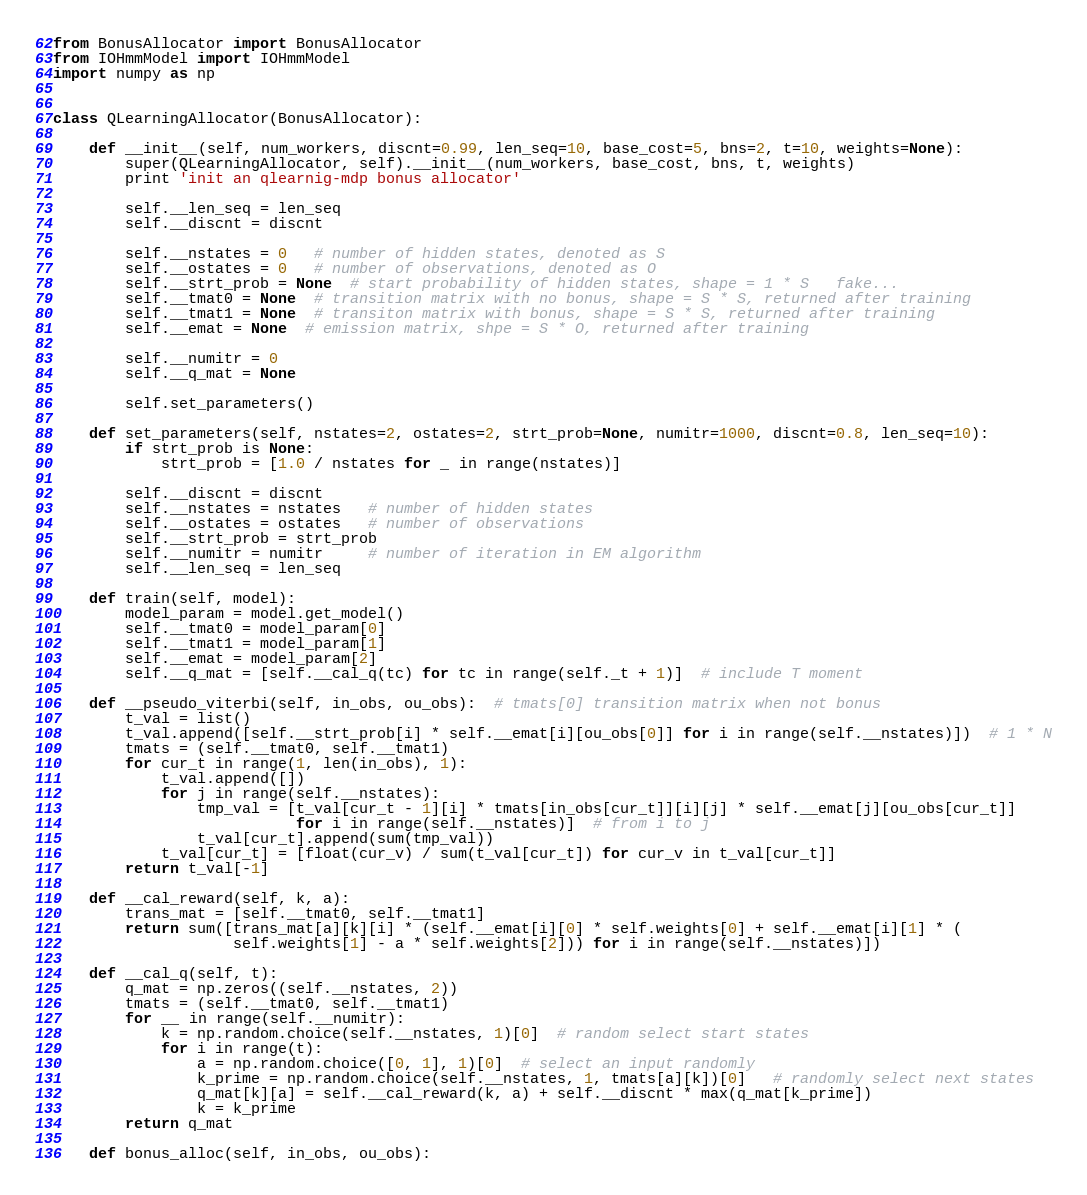Convert code to text. <code><loc_0><loc_0><loc_500><loc_500><_Python_>from BonusAllocator import BonusAllocator
from IOHmmModel import IOHmmModel
import numpy as np


class QLearningAllocator(BonusAllocator):

    def __init__(self, num_workers, discnt=0.99, len_seq=10, base_cost=5, bns=2, t=10, weights=None):
        super(QLearningAllocator, self).__init__(num_workers, base_cost, bns, t, weights)
        print 'init an qlearnig-mdp bonus allocator'

        self.__len_seq = len_seq
        self.__discnt = discnt

        self.__nstates = 0   # number of hidden states, denoted as S
        self.__ostates = 0   # number of observations, denoted as O
        self.__strt_prob = None  # start probability of hidden states, shape = 1 * S   fake...
        self.__tmat0 = None  # transition matrix with no bonus, shape = S * S, returned after training
        self.__tmat1 = None  # transiton matrix with bonus, shape = S * S, returned after training
        self.__emat = None  # emission matrix, shpe = S * O, returned after training

        self.__numitr = 0
        self.__q_mat = None

        self.set_parameters()

    def set_parameters(self, nstates=2, ostates=2, strt_prob=None, numitr=1000, discnt=0.8, len_seq=10):
        if strt_prob is None:
            strt_prob = [1.0 / nstates for _ in range(nstates)]

        self.__discnt = discnt
        self.__nstates = nstates   # number of hidden states
        self.__ostates = ostates   # number of observations
        self.__strt_prob = strt_prob
        self.__numitr = numitr     # number of iteration in EM algorithm
        self.__len_seq = len_seq

    def train(self, model):
        model_param = model.get_model()
        self.__tmat0 = model_param[0]
        self.__tmat1 = model_param[1]
        self.__emat = model_param[2]
        self.__q_mat = [self.__cal_q(tc) for tc in range(self._t + 1)]  # include T moment

    def __pseudo_viterbi(self, in_obs, ou_obs):  # tmats[0] transition matrix when not bonus
        t_val = list()
        t_val.append([self.__strt_prob[i] * self.__emat[i][ou_obs[0]] for i in range(self.__nstates)])  # 1 * N
        tmats = (self.__tmat0, self.__tmat1)
        for cur_t in range(1, len(in_obs), 1):
            t_val.append([])
            for j in range(self.__nstates):
                tmp_val = [t_val[cur_t - 1][i] * tmats[in_obs[cur_t]][i][j] * self.__emat[j][ou_obs[cur_t]]
                           for i in range(self.__nstates)]  # from i to j
                t_val[cur_t].append(sum(tmp_val))
            t_val[cur_t] = [float(cur_v) / sum(t_val[cur_t]) for cur_v in t_val[cur_t]]
        return t_val[-1]

    def __cal_reward(self, k, a):
        trans_mat = [self.__tmat0, self.__tmat1]
        return sum([trans_mat[a][k][i] * (self.__emat[i][0] * self.weights[0] + self.__emat[i][1] * (
                    self.weights[1] - a * self.weights[2])) for i in range(self.__nstates)])

    def __cal_q(self, t):
        q_mat = np.zeros((self.__nstates, 2))
        tmats = (self.__tmat0, self.__tmat1)
        for __ in range(self.__numitr):
            k = np.random.choice(self.__nstates, 1)[0]  # random select start states
            for i in range(t):
                a = np.random.choice([0, 1], 1)[0]  # select an input randomly
                k_prime = np.random.choice(self.__nstates, 1, tmats[a][k])[0]   # randomly select next states
                q_mat[k][a] = self.__cal_reward(k, a) + self.__discnt * max(q_mat[k_prime])
                k = k_prime
        return q_mat

    def bonus_alloc(self, in_obs, ou_obs):</code> 